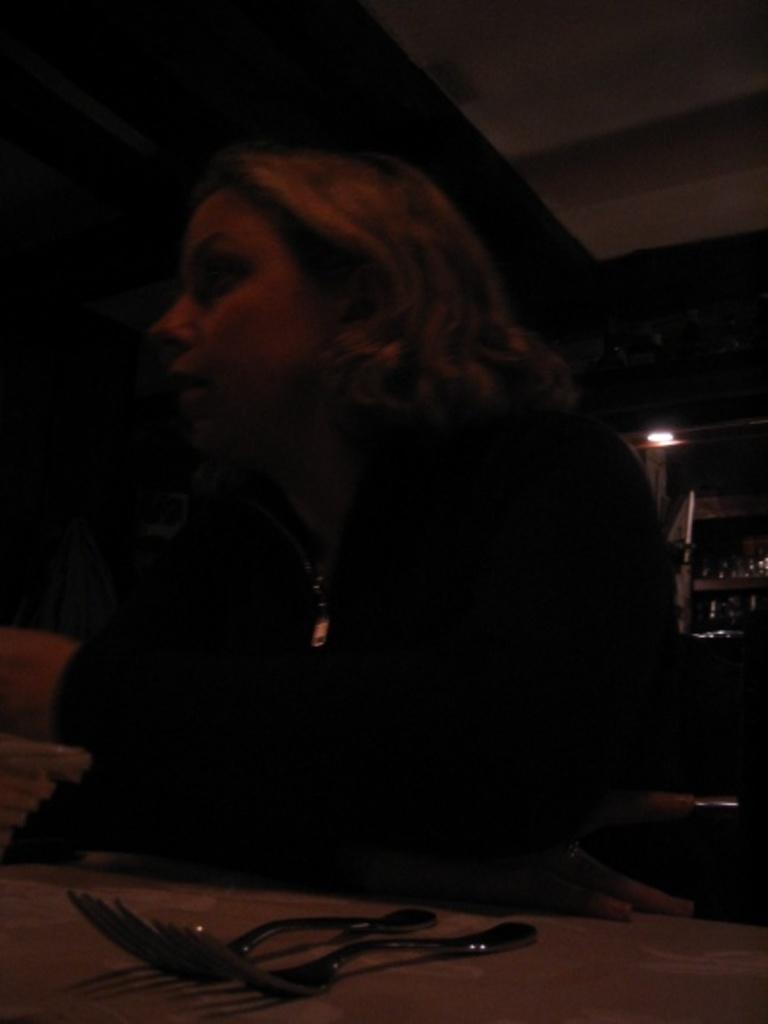Please provide a concise description of this image. In the photograph there is a table in front of the table, a woman is sitting on the table there are two forks, behind her there is a light and some bottles. 